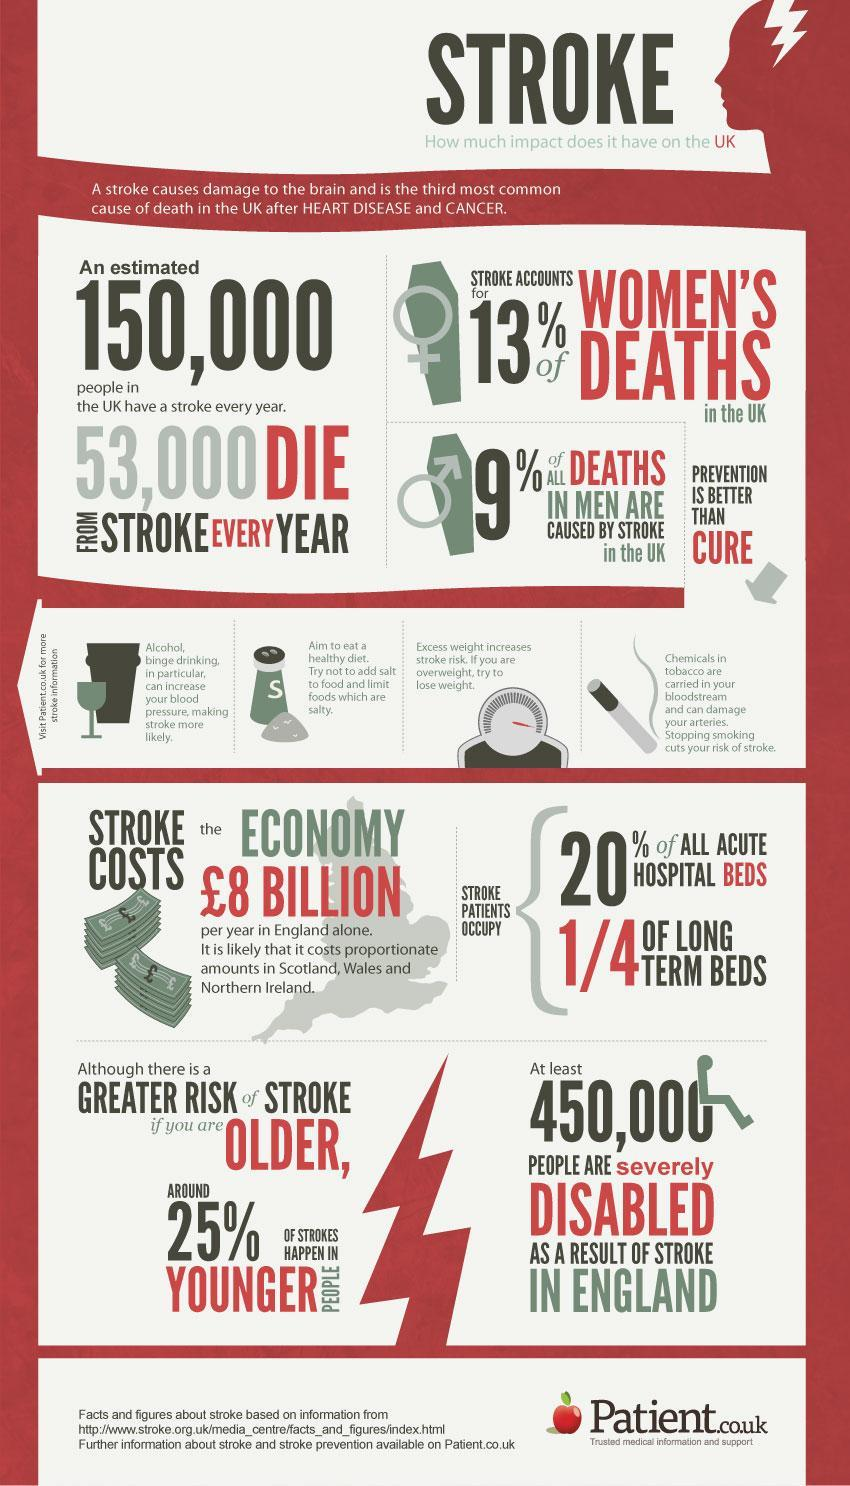What is the percentage of strokes that occur in elder people?
Answer the question with a short phrase. 75% What is the most common cause of death in the UK? Heart Disease How many people survive strokes every year? 97000 What is the second most common cause of death in the UK? Cancer 